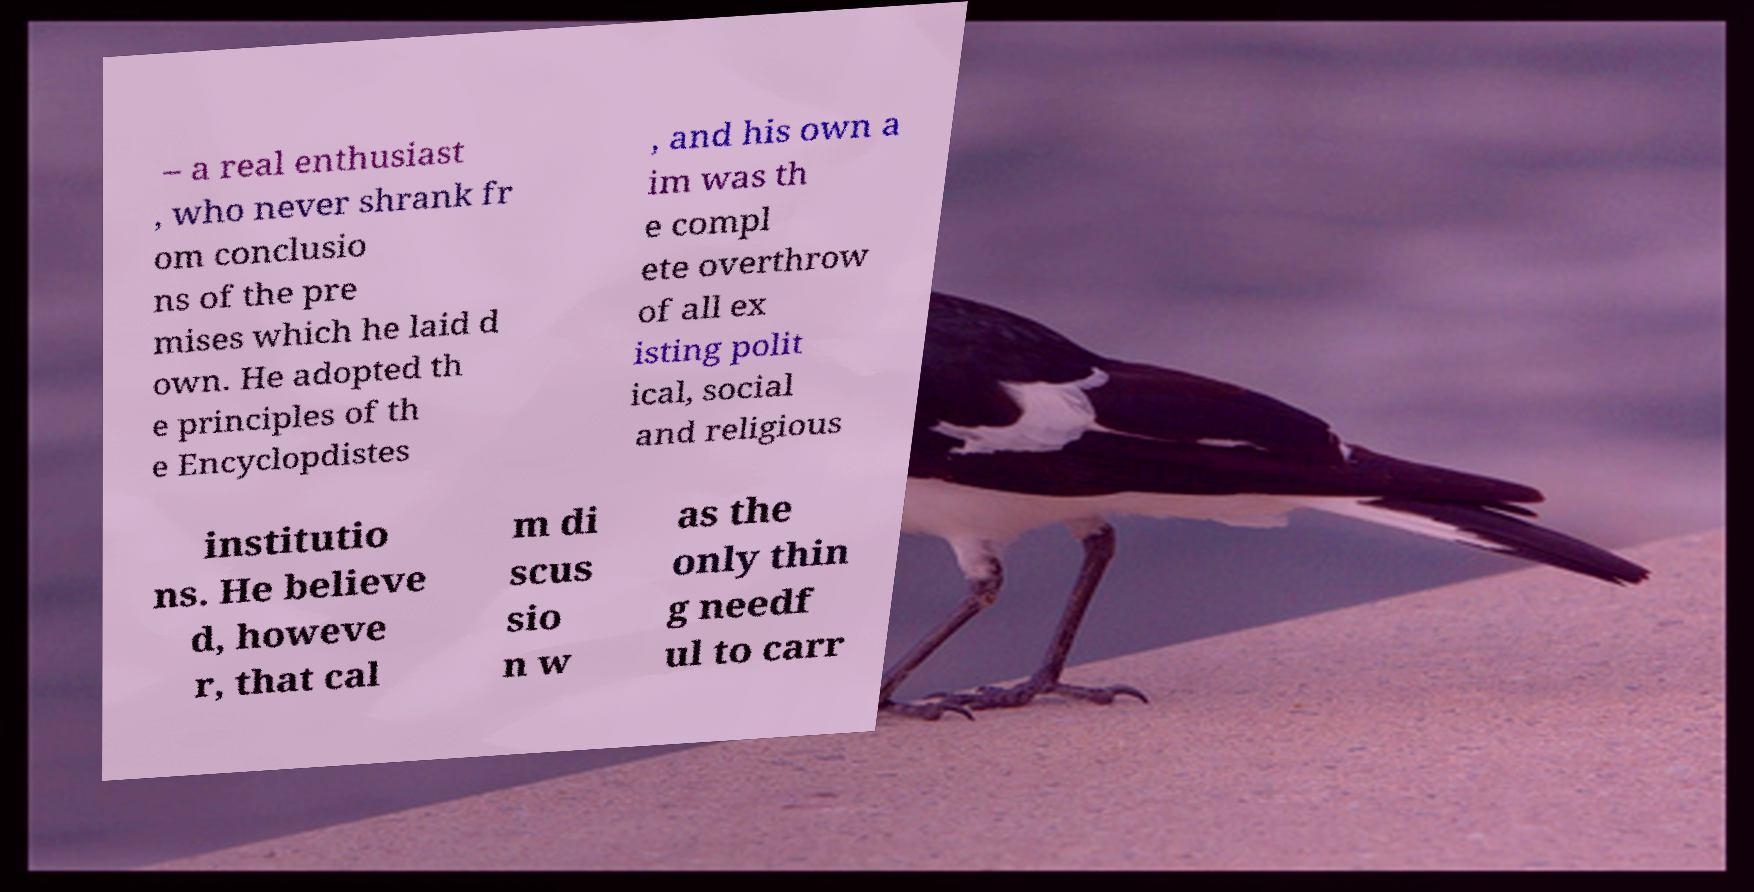What messages or text are displayed in this image? I need them in a readable, typed format. – a real enthusiast , who never shrank fr om conclusio ns of the pre mises which he laid d own. He adopted th e principles of th e Encyclopdistes , and his own a im was th e compl ete overthrow of all ex isting polit ical, social and religious institutio ns. He believe d, howeve r, that cal m di scus sio n w as the only thin g needf ul to carr 